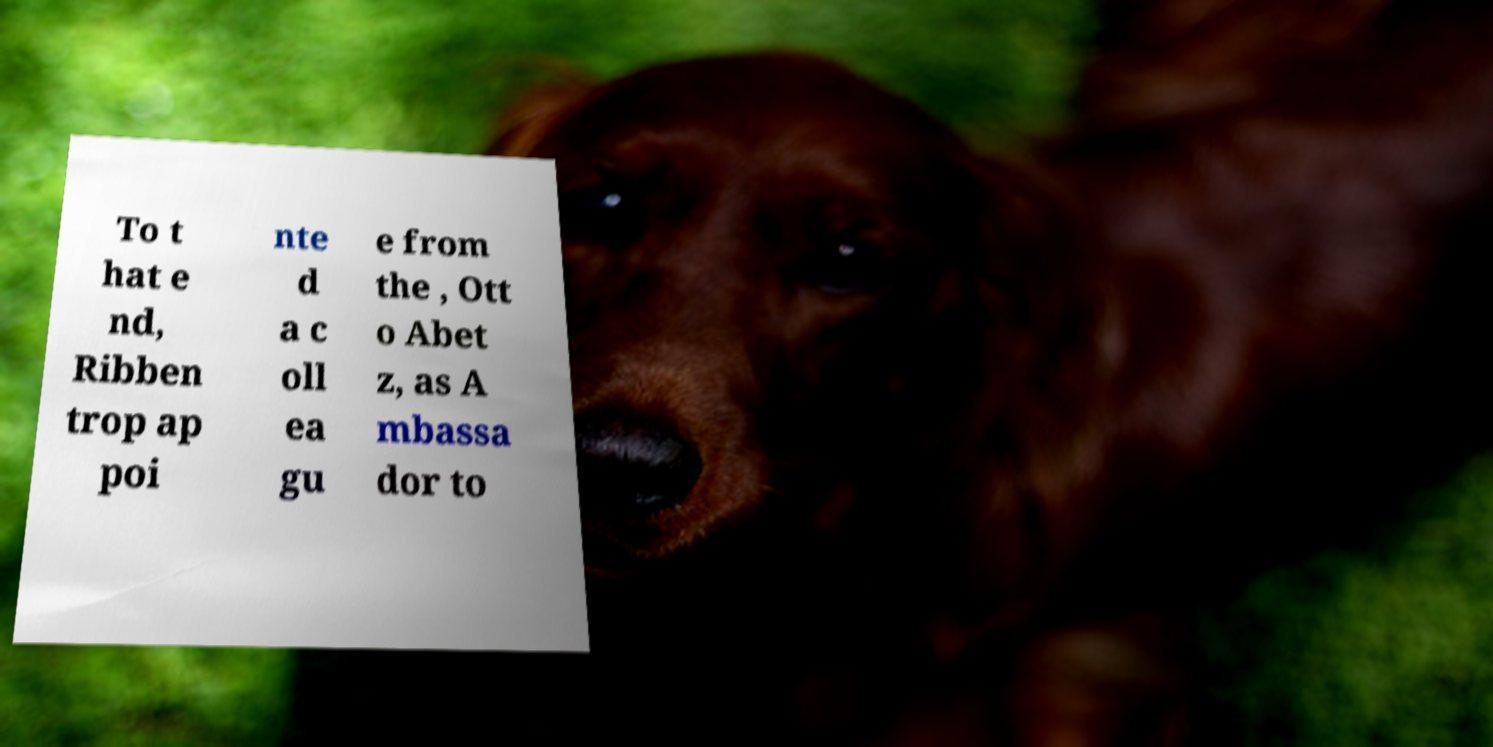Could you extract and type out the text from this image? To t hat e nd, Ribben trop ap poi nte d a c oll ea gu e from the , Ott o Abet z, as A mbassa dor to 